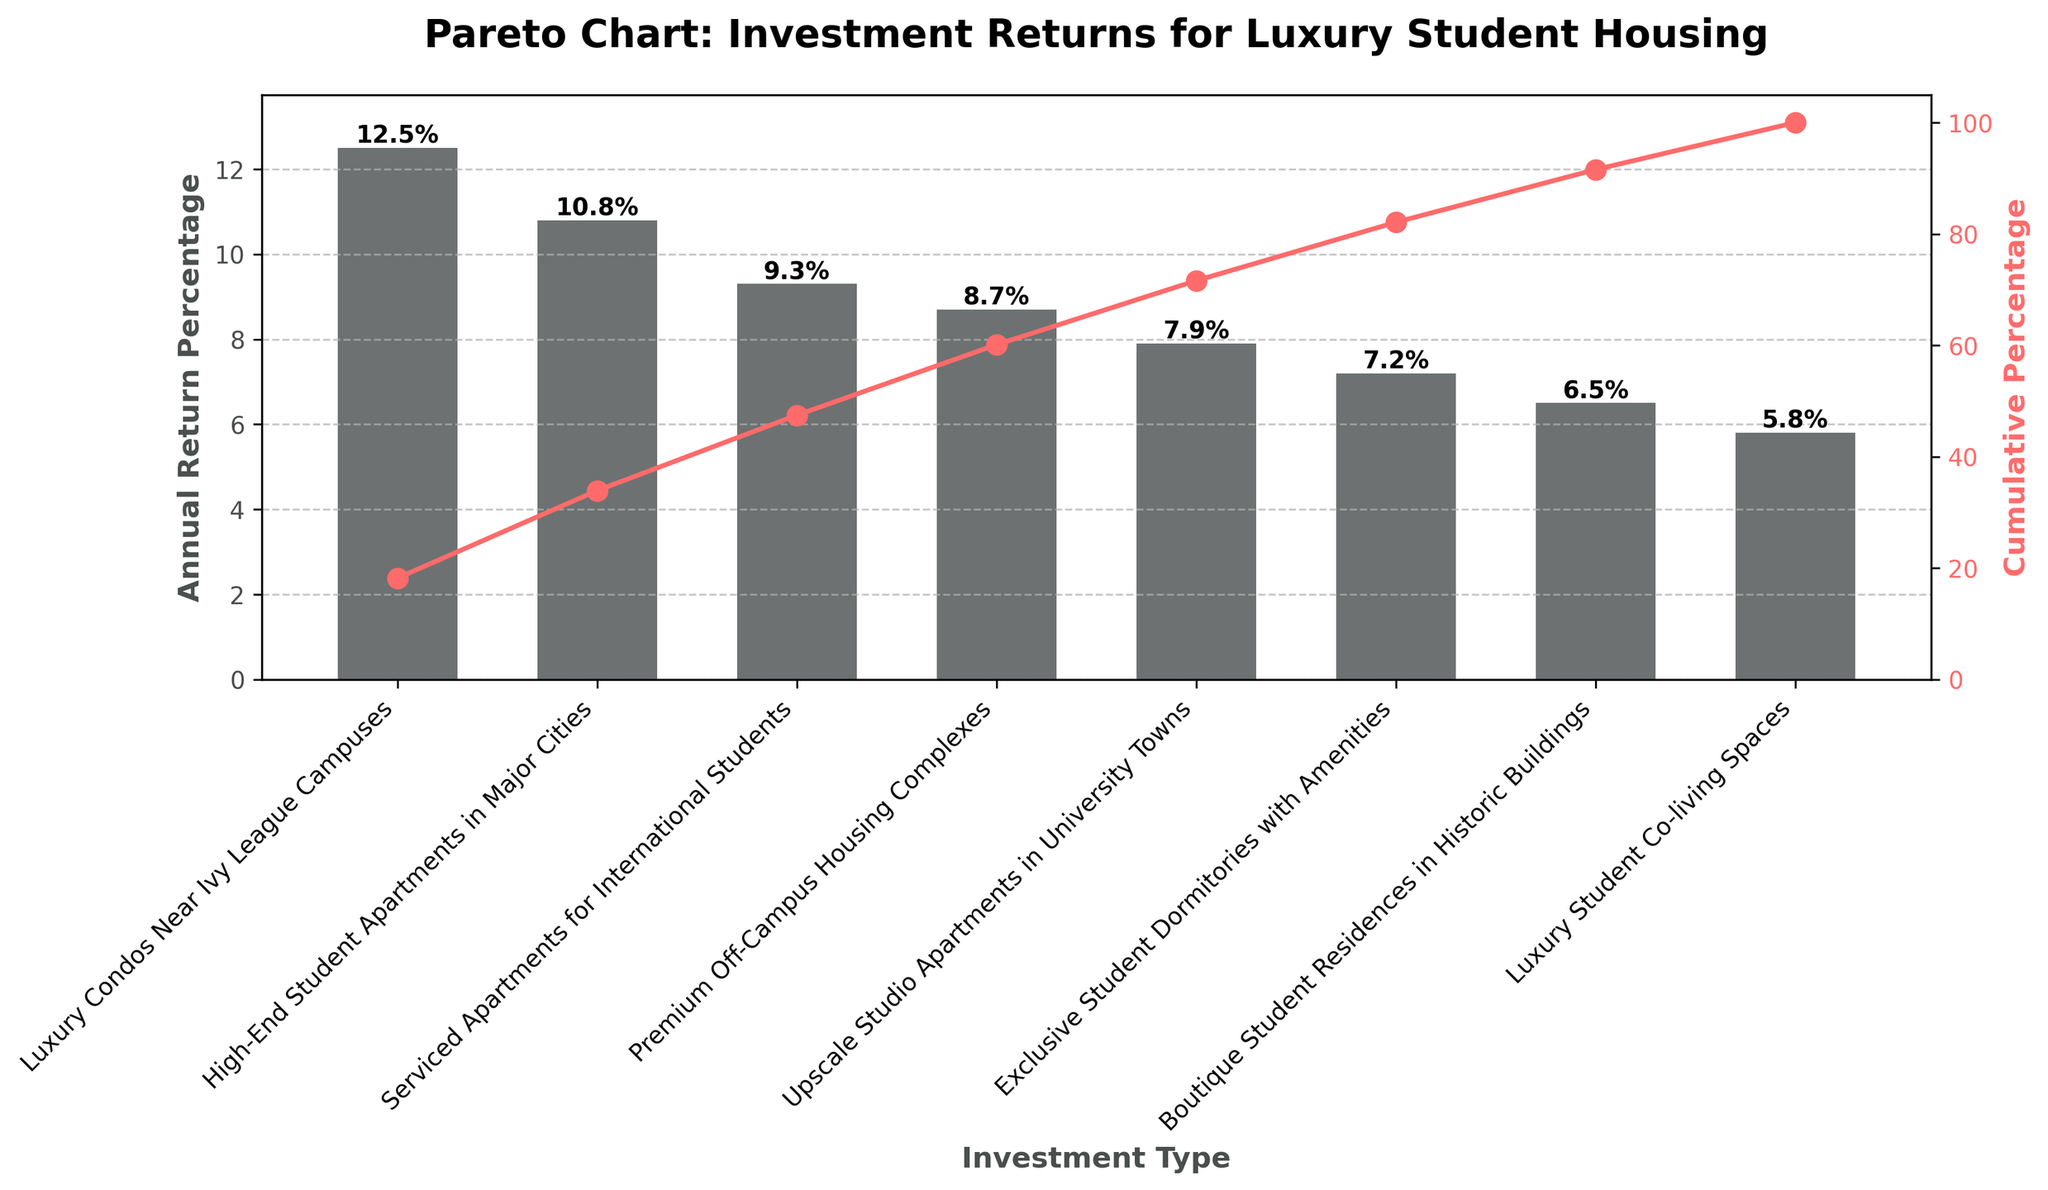Which investment type has the highest annual return percentage? The luxury condos near Ivy league campuses have the highest bar height, which corresponds to the highest annual return percentage.
Answer: Luxury Condos Near Ivy League Campuses What is the cumulative percentage after the third investment type? Identify and add the cumulative percentages of the first three investment types plotted on the secondary y-axis.
Answer: 32.6% How many investment types have an annual return percentage above 8%? Count the number of bars with heights higher than 8% on the primary y-axis.
Answer: 4 Which investment type contributes the least to the cumulative percentage? The smallest bar or the rightmost bar corresponds to the least contribution, which is luxury student co-living spaces.
Answer: Luxury Student Co-living Spaces What is the difference in annual return percentage between the most and least profitable investments? Subtract the annual return percentage of the least profitable investment from the most profitable investment: 12.5% - 5.8% = 6.7%.
Answer: 6.7% What is the color and style of the line representing the cumulative percentage? The line color is red, with circular markers and a solid style, as shown visually.
Answer: Red, with circular markers, and a solid line Which investment types combine to make up around 50% of the cumulative percentage? By examining cumulative percentage on the secondary y-axis, the first four investment types add up to roughly 50%.
Answer: Luxury Condos Near Ivy League Campuses, High-End Student Apartments in Major Cities, Serviced Apartments for International Students How does the cumulative percentage change between the second and fourth investment types? By looking at the figure, the cumulative percentage increases from the second to the fourth investment types: 23.3% to approximately 41.3%.
Answer: Increases by 18% Which two investment types are closest in their annual return percentage values, and what are they? The investment types closest in height are "Premium Off-Campus Housing Complexes" and "Upscale Studio Apartments in University Towns" with 8.7% and 7.9% respectively.
Answer: Premium Off-Campus Housing Complexes, Upscale Studio Apartments in University Towns 